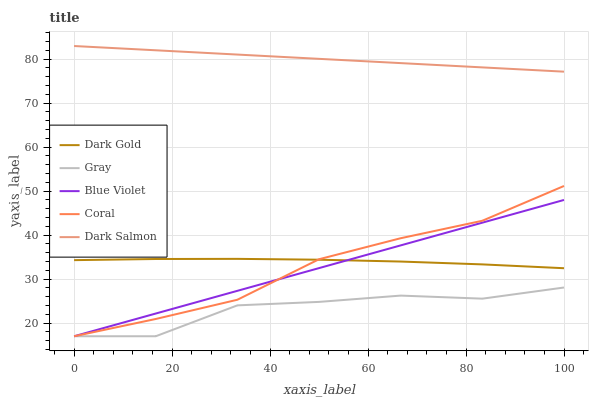Does Coral have the minimum area under the curve?
Answer yes or no. No. Does Coral have the maximum area under the curve?
Answer yes or no. No. Is Coral the smoothest?
Answer yes or no. No. Is Coral the roughest?
Answer yes or no. No. Does Dark Salmon have the lowest value?
Answer yes or no. No. Does Coral have the highest value?
Answer yes or no. No. Is Dark Gold less than Dark Salmon?
Answer yes or no. Yes. Is Dark Salmon greater than Dark Gold?
Answer yes or no. Yes. Does Dark Gold intersect Dark Salmon?
Answer yes or no. No. 